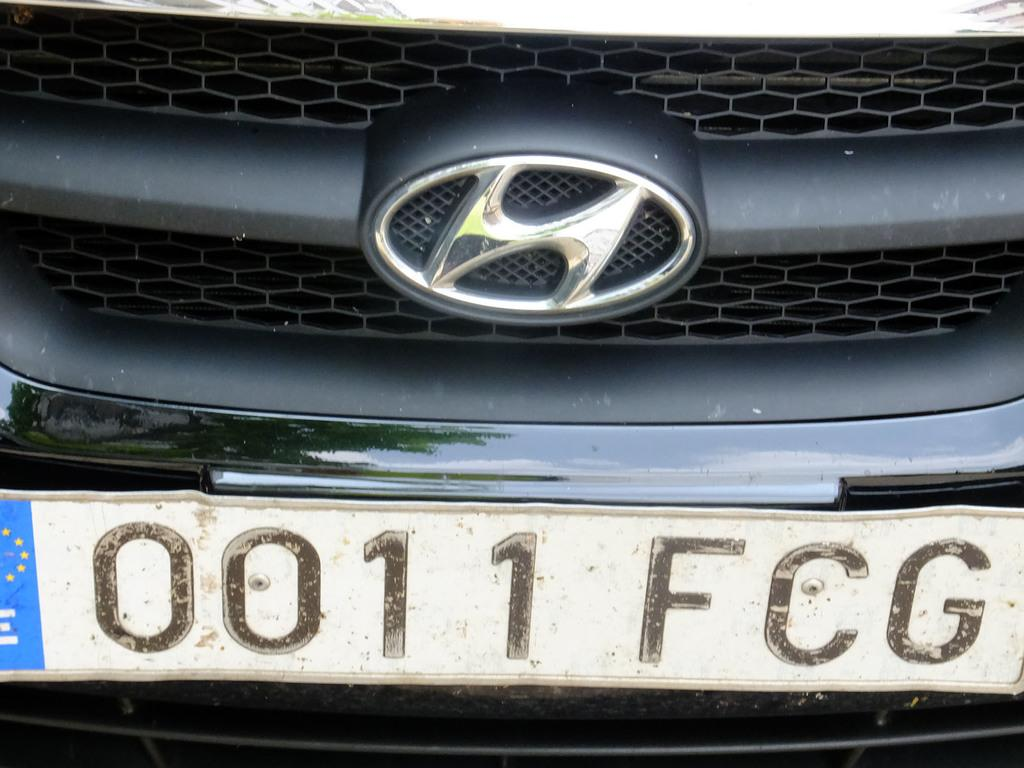<image>
Give a short and clear explanation of the subsequent image. a car logo with the numbers 00 on it 